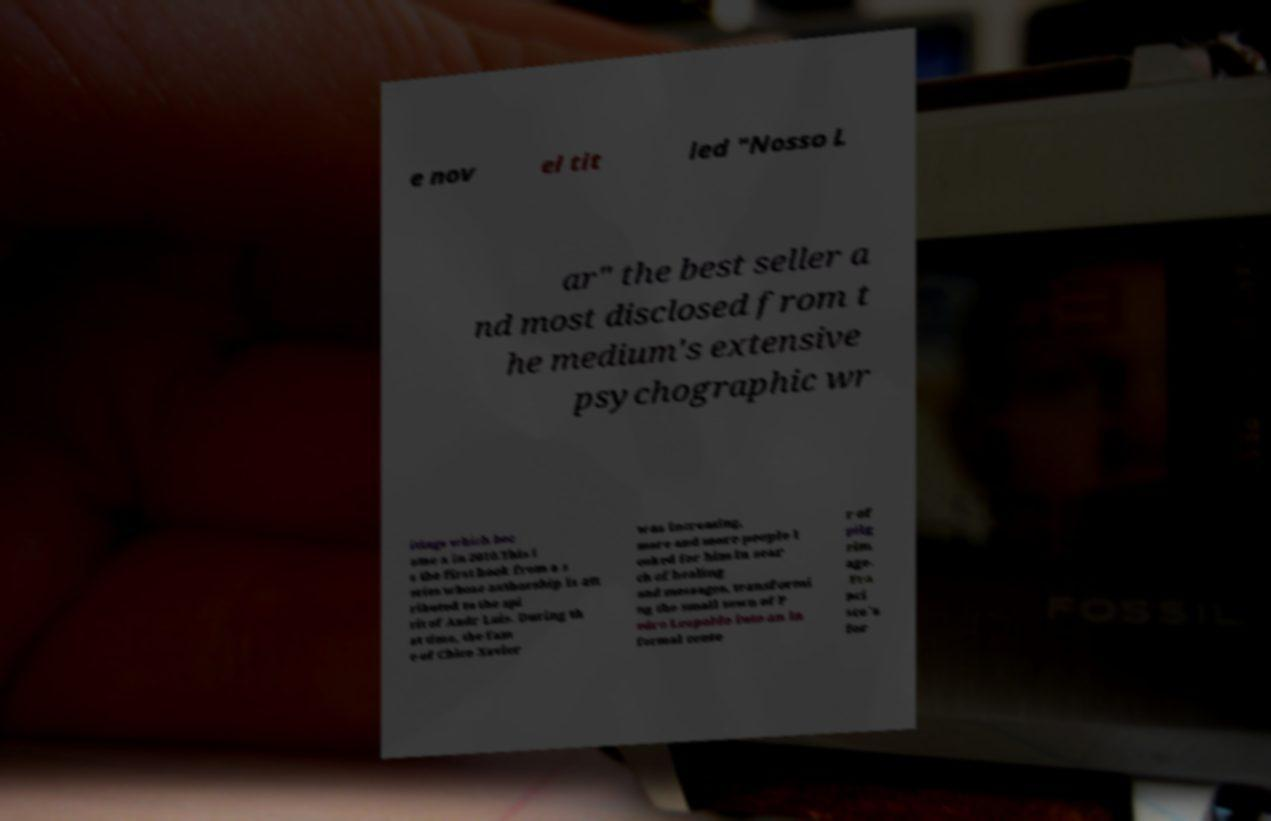Please read and relay the text visible in this image. What does it say? e nov el tit led "Nosso L ar" the best seller a nd most disclosed from t he medium's extensive psychographic wr itings which bec ame a in 2010.This i s the first book from a s eries whose authorship is att ributed to the spi rit of Andr Luis. During th at time, the fam e of Chico Xavier was increasing, more and more people l ooked for him in sear ch of healing and messages, transformi ng the small town of P edro Leopoldo into an in formal cente r of pilg rim age. Fra nci sco´s for 